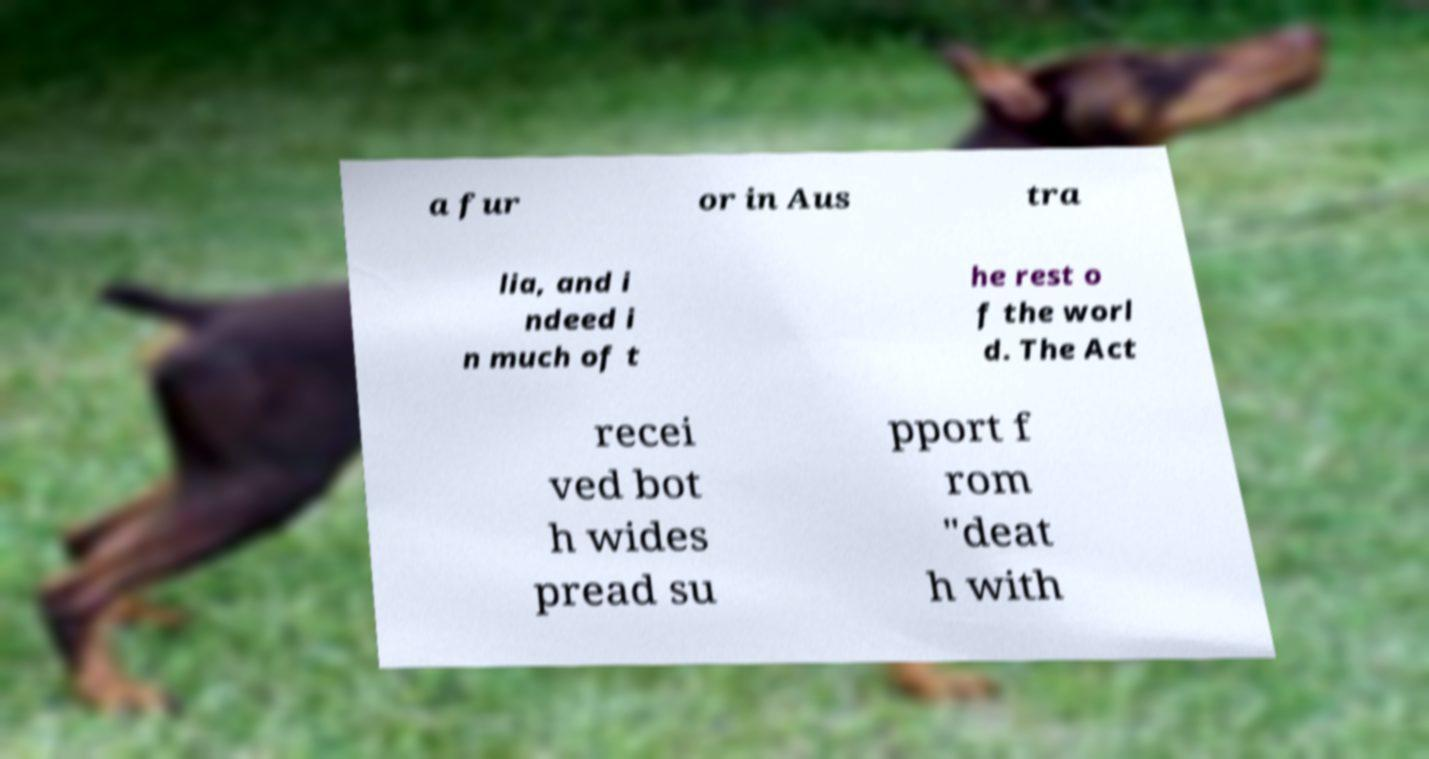Can you read and provide the text displayed in the image?This photo seems to have some interesting text. Can you extract and type it out for me? a fur or in Aus tra lia, and i ndeed i n much of t he rest o f the worl d. The Act recei ved bot h wides pread su pport f rom "deat h with 